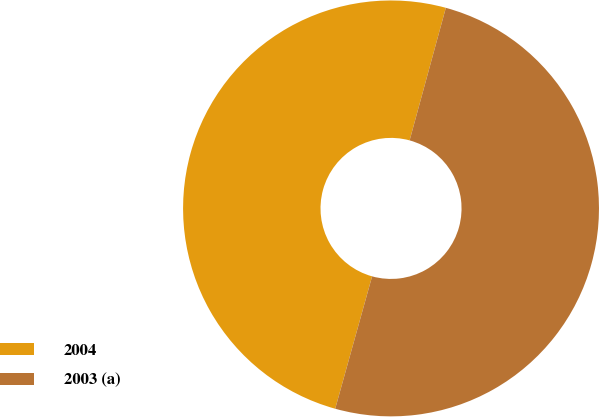<chart> <loc_0><loc_0><loc_500><loc_500><pie_chart><fcel>2004<fcel>2003 (a)<nl><fcel>49.92%<fcel>50.08%<nl></chart> 